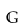Convert formula to latex. <formula><loc_0><loc_0><loc_500><loc_500>\mathbb { G }</formula> 